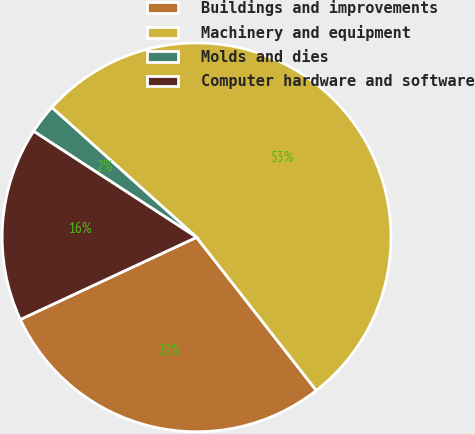<chart> <loc_0><loc_0><loc_500><loc_500><pie_chart><fcel>Buildings and improvements<fcel>Machinery and equipment<fcel>Molds and dies<fcel>Computer hardware and software<nl><fcel>28.62%<fcel>52.81%<fcel>2.45%<fcel>16.13%<nl></chart> 